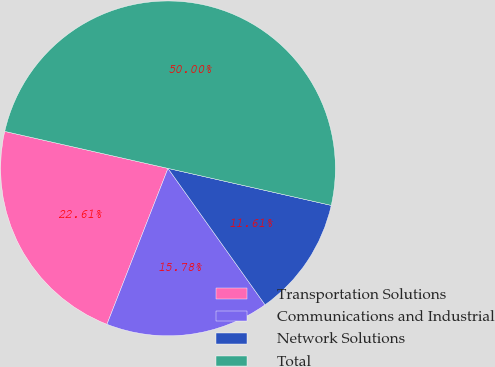<chart> <loc_0><loc_0><loc_500><loc_500><pie_chart><fcel>Transportation Solutions<fcel>Communications and Industrial<fcel>Network Solutions<fcel>Total<nl><fcel>22.61%<fcel>15.78%<fcel>11.61%<fcel>50.0%<nl></chart> 